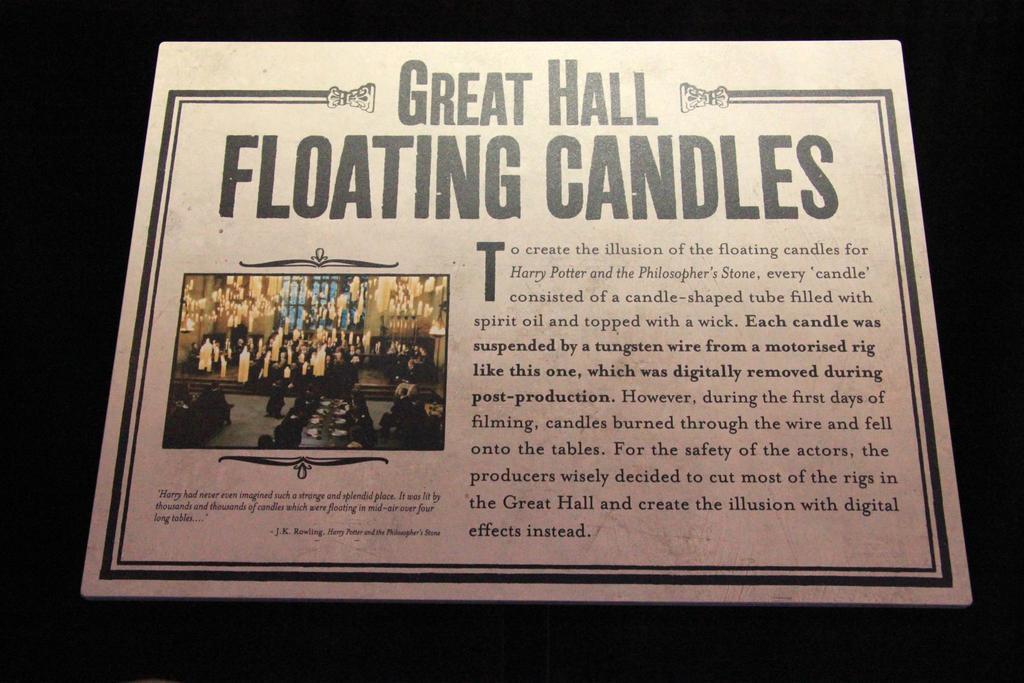What kind of hall is listed?
Your answer should be very brief. Great. 